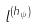<formula> <loc_0><loc_0><loc_500><loc_500>l ^ { ( h _ { \psi } ) }</formula> 